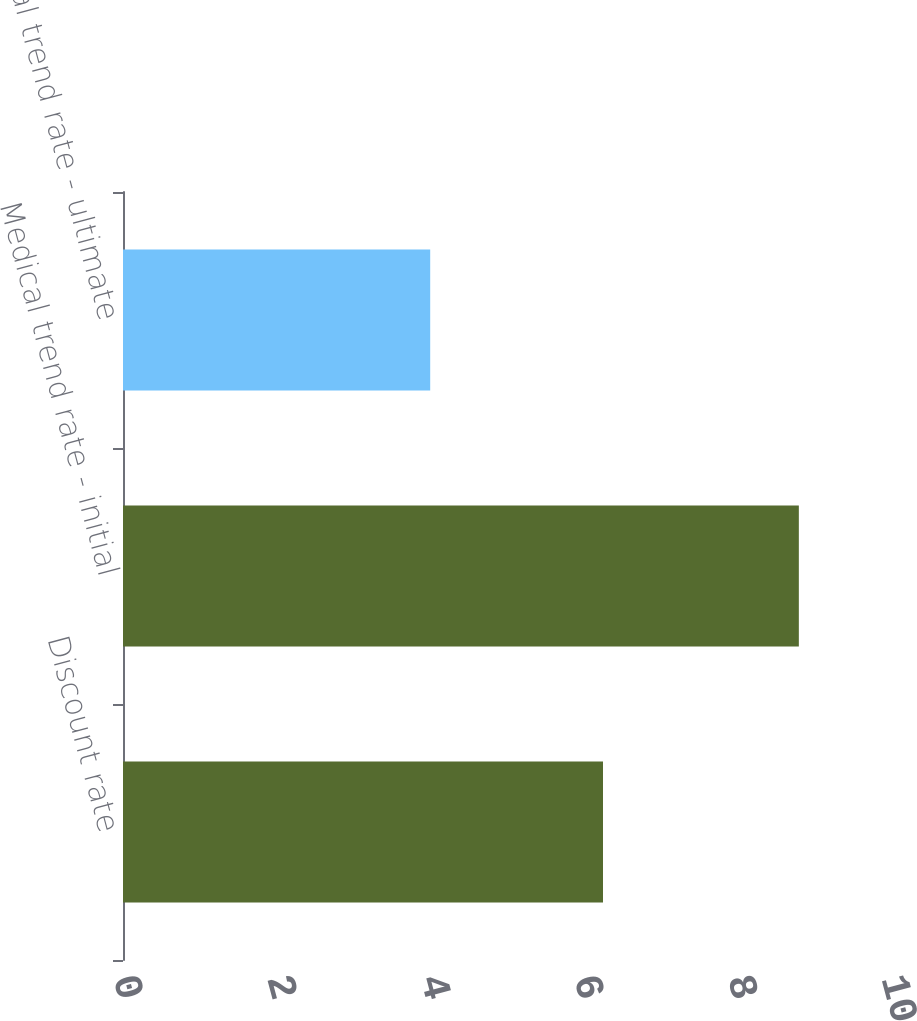Convert chart to OTSL. <chart><loc_0><loc_0><loc_500><loc_500><bar_chart><fcel>Discount rate<fcel>Medical trend rate - initial<fcel>Medical trend rate - ultimate<nl><fcel>6.25<fcel>8.8<fcel>4<nl></chart> 